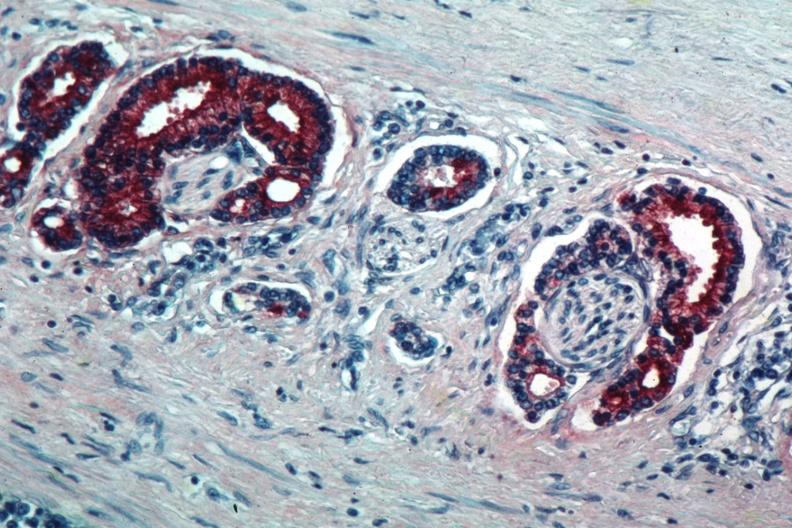does this image show med immunostain for prostate specific antigen shows marked staining in perineural neoplasm?
Answer the question using a single word or phrase. Yes 